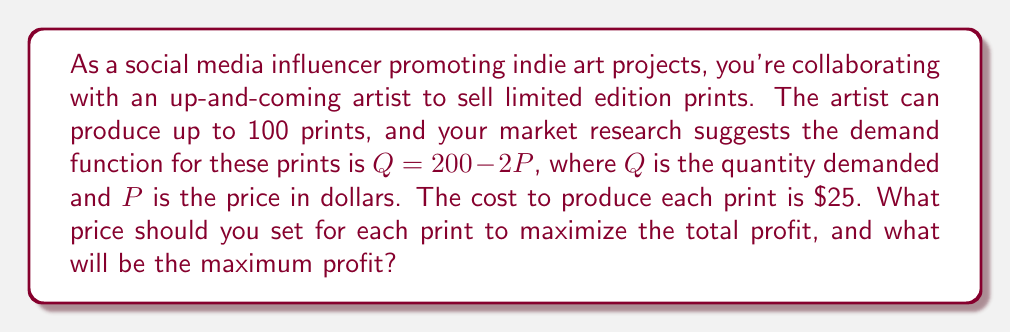What is the answer to this math problem? To solve this problem, we'll follow these steps:

1) First, let's define our profit function. Profit is revenue minus cost:
   $\text{Profit} = \text{Revenue} - \text{Cost}$

2) Revenue is price times quantity: $R = PQ$
   Cost is the number of prints times the cost per print: $C = 25Q$

3) Substituting the demand function $Q = 200 - 2P$ into our profit function:
   $\text{Profit} = P(200-2P) - 25(200-2P)$

4) Expanding this:
   $\text{Profit} = 200P - 2P^2 - 5000 + 50P = -2P^2 + 250P - 5000$

5) To find the maximum profit, we need to find where the derivative of this function equals zero:
   $\frac{d(\text{Profit})}{dP} = -4P + 250 = 0$

6) Solving this:
   $-4P + 250 = 0$
   $-4P = -250$
   $P = 62.5$

7) The second derivative is negative ($-4$), confirming this is a maximum.

8) Now we can calculate the quantity at this price:
   $Q = 200 - 2(62.5) = 75$

9) Finally, we can calculate the maximum profit:
   $\text{Profit} = 62.5 * 75 - 25 * 75 = 4687.5 - 1875 = 2812.5$

Therefore, the optimal price is $62.50 per print, which will result in selling 75 prints and a maximum profit of $2812.50.
Answer: Optimal price: $62.50 per print
Maximum profit: $2812.50 